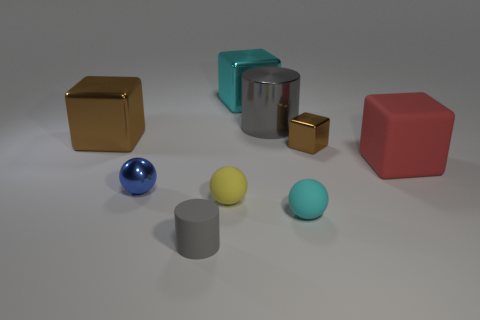Subtract all cylinders. How many objects are left? 7 Subtract all tiny gray shiny blocks. Subtract all rubber cubes. How many objects are left? 8 Add 3 small gray cylinders. How many small gray cylinders are left? 4 Add 6 yellow matte balls. How many yellow matte balls exist? 7 Subtract 1 red blocks. How many objects are left? 8 